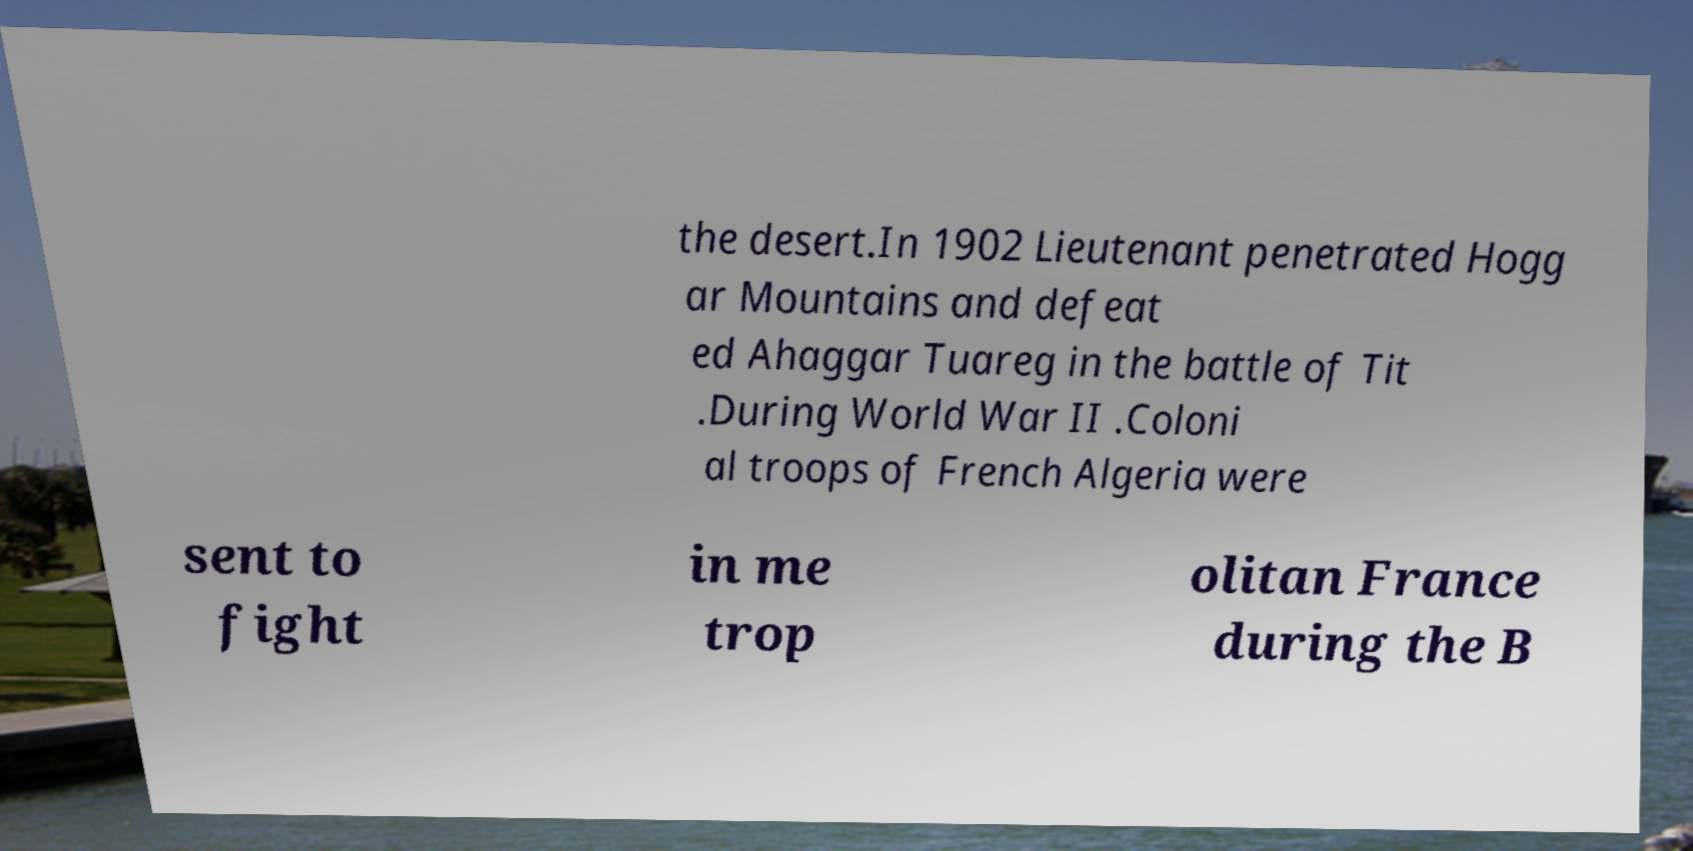Please read and relay the text visible in this image. What does it say? the desert.In 1902 Lieutenant penetrated Hogg ar Mountains and defeat ed Ahaggar Tuareg in the battle of Tit .During World War II .Coloni al troops of French Algeria were sent to fight in me trop olitan France during the B 